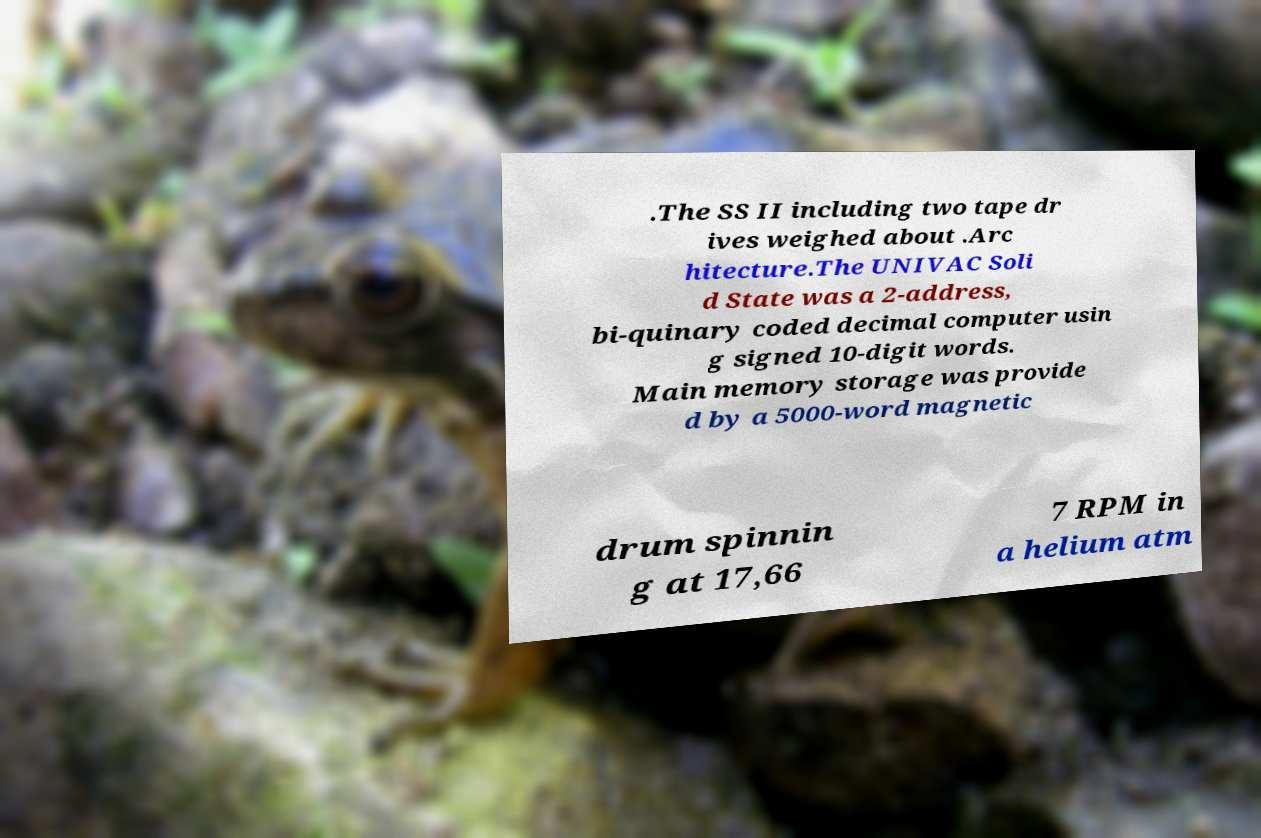Please read and relay the text visible in this image. What does it say? .The SS II including two tape dr ives weighed about .Arc hitecture.The UNIVAC Soli d State was a 2-address, bi-quinary coded decimal computer usin g signed 10-digit words. Main memory storage was provide d by a 5000-word magnetic drum spinnin g at 17,66 7 RPM in a helium atm 